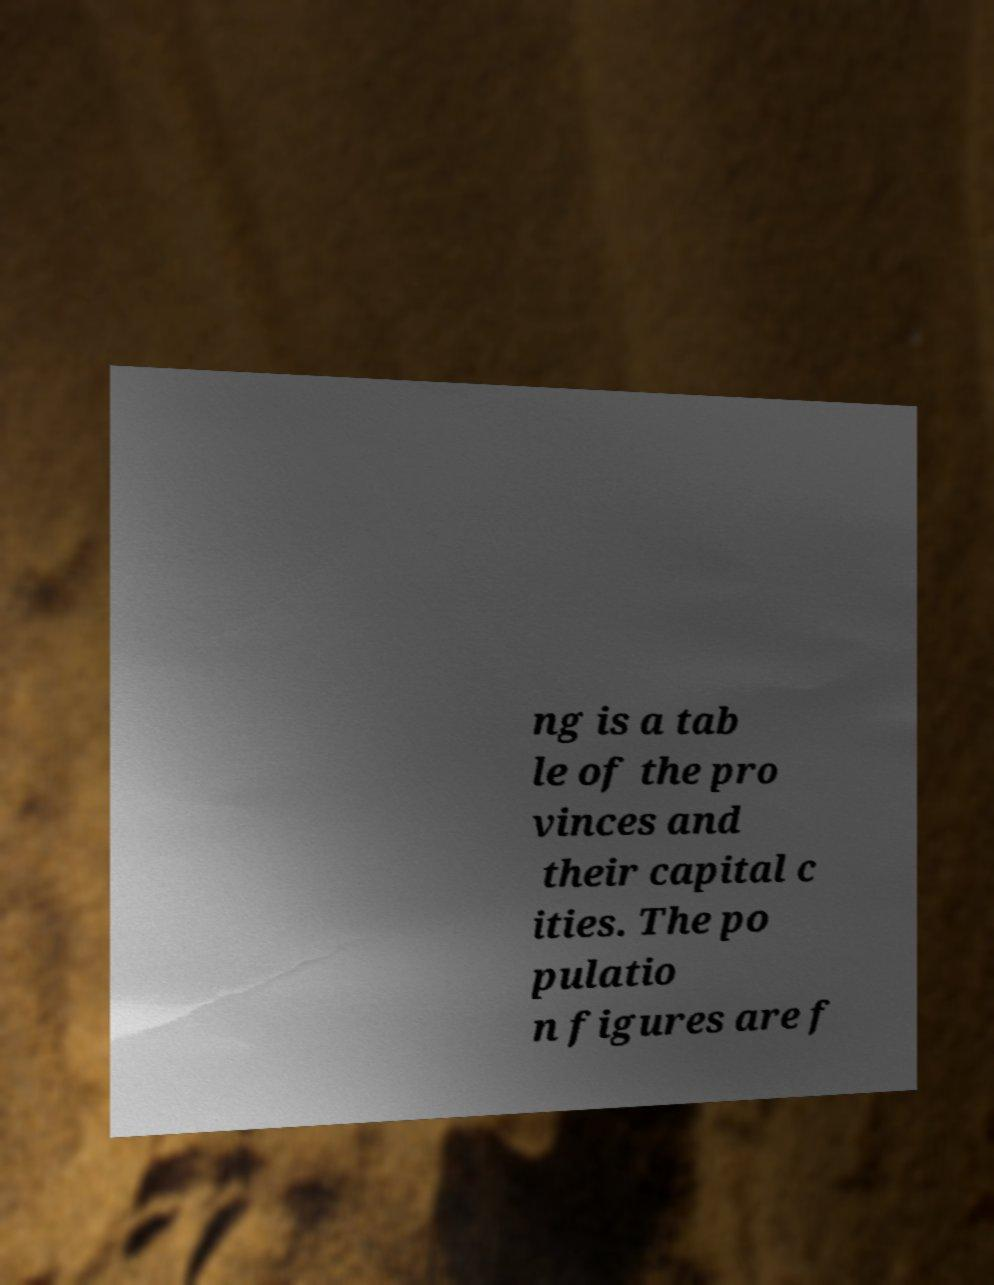For documentation purposes, I need the text within this image transcribed. Could you provide that? ng is a tab le of the pro vinces and their capital c ities. The po pulatio n figures are f 